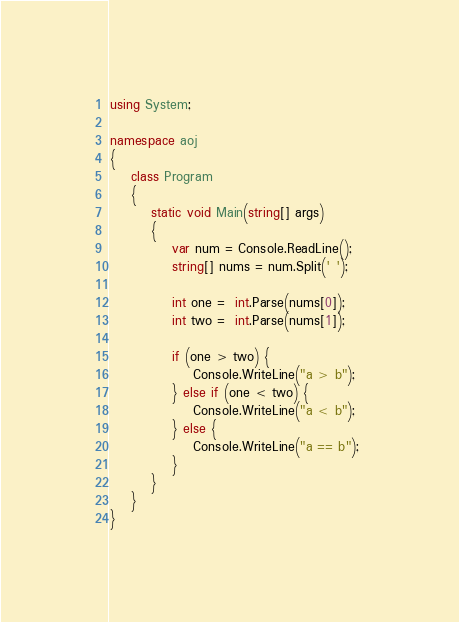Convert code to text. <code><loc_0><loc_0><loc_500><loc_500><_C#_>using System;

namespace aoj
{
    class Program
    {
        static void Main(string[] args)
        {
            var num = Console.ReadLine();
            string[] nums = num.Split(' ');   

            int one =  int.Parse(nums[0]);
            int two =  int.Parse(nums[1]);

            if (one > two) {
                Console.WriteLine("a > b");
            } else if (one < two) {
                Console.WriteLine("a < b");
            } else {
                Console.WriteLine("a == b");
            } 
        }
    }
}

</code> 